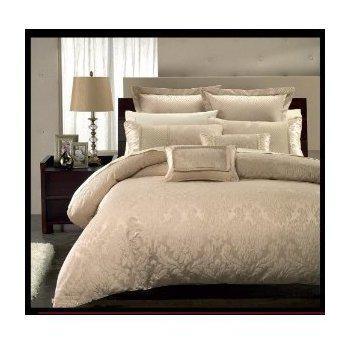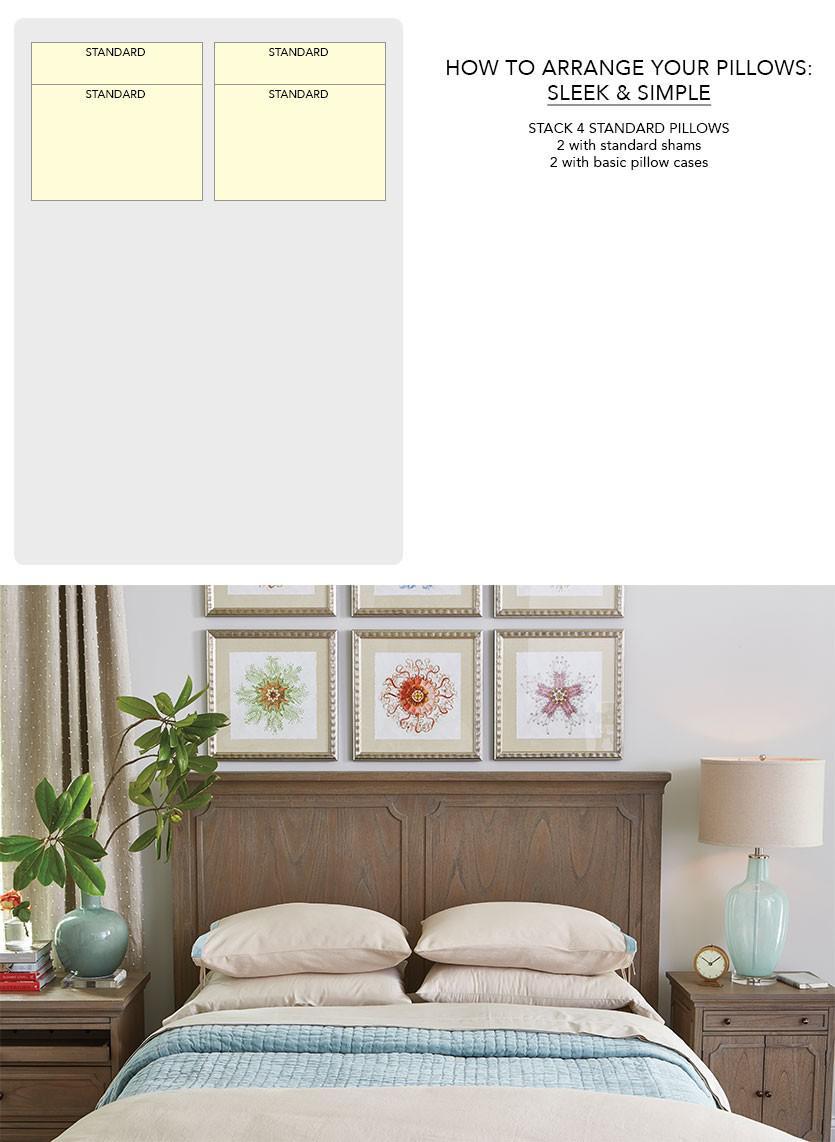The first image is the image on the left, the second image is the image on the right. Assess this claim about the two images: "The left and right image contains the same number of pillow place on the bed.". Correct or not? Answer yes or no. No. The first image is the image on the left, the second image is the image on the right. Analyze the images presented: Is the assertion "The right image shows pillows on a sofa-shaped dark bed that is angled facing rightward." valid? Answer yes or no. No. 